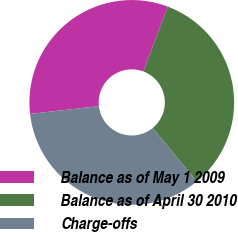Convert chart. <chart><loc_0><loc_0><loc_500><loc_500><pie_chart><fcel>Balance as of May 1 2009<fcel>Balance as of April 30 2010<fcel>Charge-offs<nl><fcel>32.52%<fcel>33.33%<fcel>34.15%<nl></chart> 